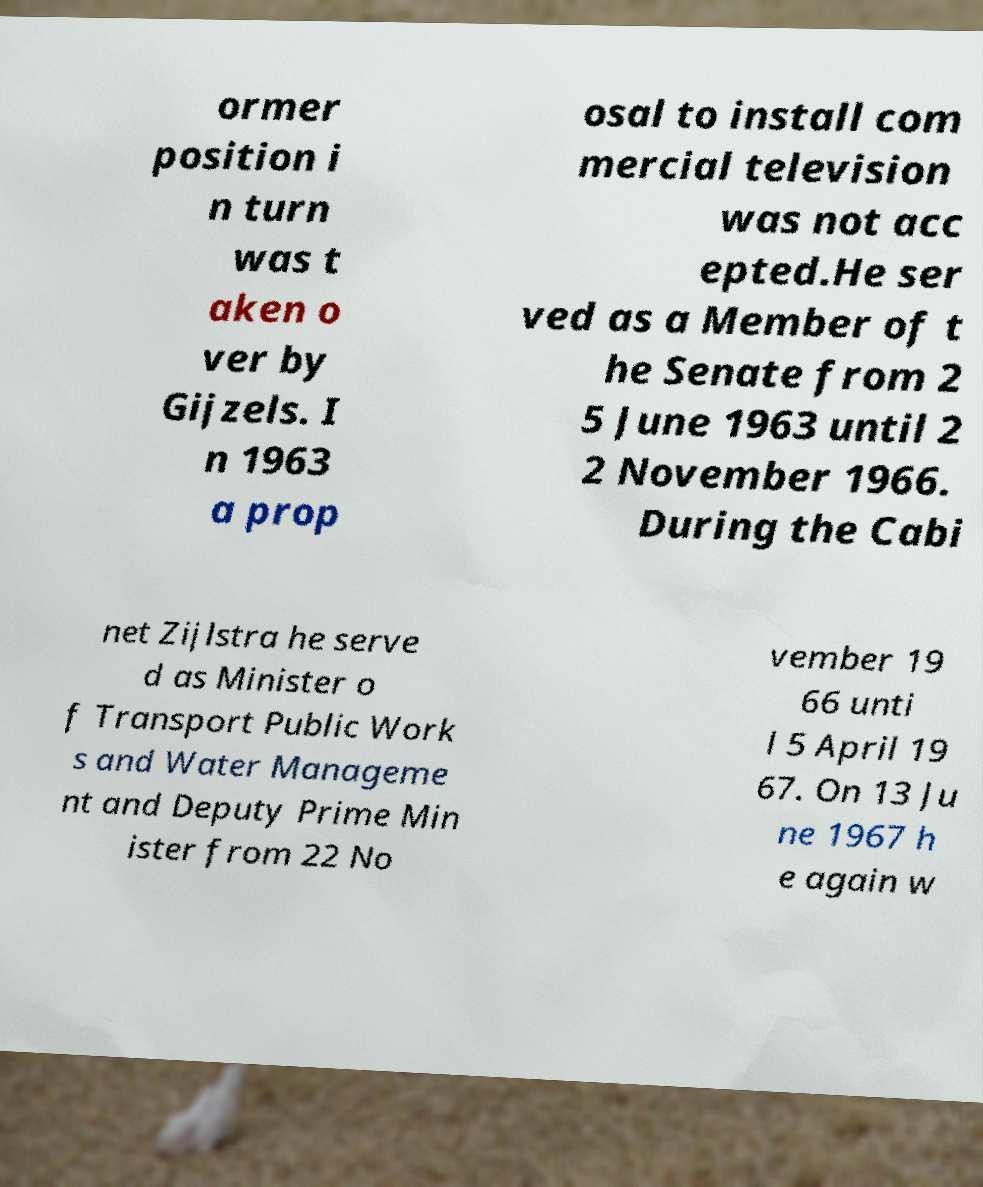There's text embedded in this image that I need extracted. Can you transcribe it verbatim? ormer position i n turn was t aken o ver by Gijzels. I n 1963 a prop osal to install com mercial television was not acc epted.He ser ved as a Member of t he Senate from 2 5 June 1963 until 2 2 November 1966. During the Cabi net Zijlstra he serve d as Minister o f Transport Public Work s and Water Manageme nt and Deputy Prime Min ister from 22 No vember 19 66 unti l 5 April 19 67. On 13 Ju ne 1967 h e again w 